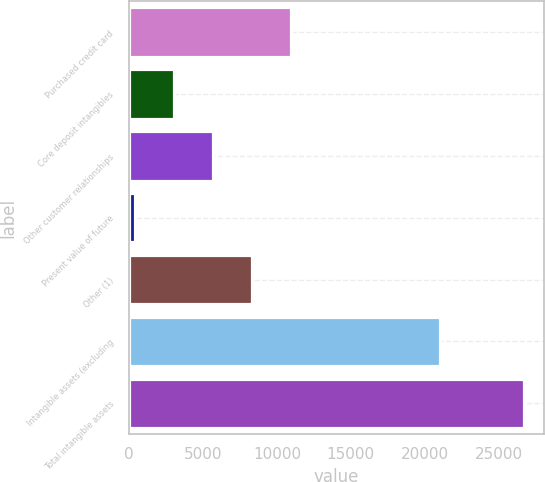Convert chart. <chart><loc_0><loc_0><loc_500><loc_500><bar_chart><fcel>Purchased credit card<fcel>Core deposit intangibles<fcel>Other customer relationships<fcel>Present value of future<fcel>Other (1)<fcel>Intangible assets (excluding<fcel>Total intangible assets<nl><fcel>10932.2<fcel>3044.3<fcel>5673.6<fcel>415<fcel>8302.9<fcel>21051<fcel>26708<nl></chart> 